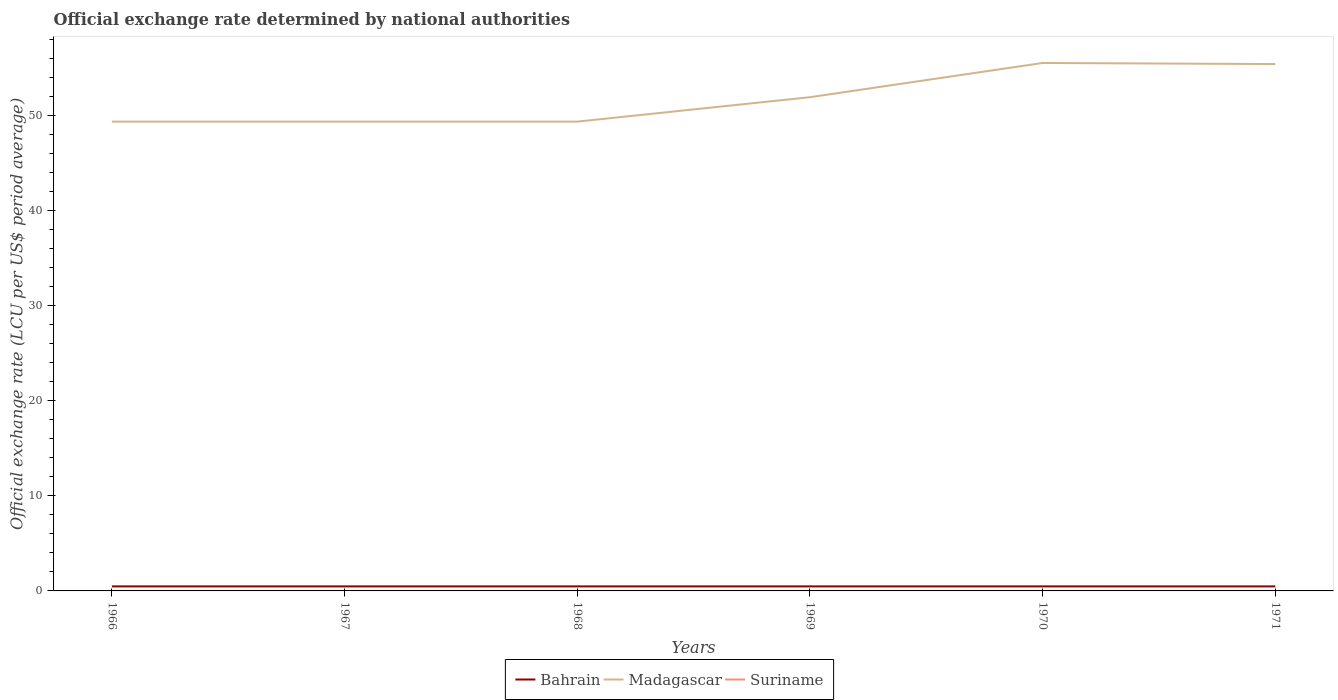Does the line corresponding to Bahrain intersect with the line corresponding to Madagascar?
Give a very brief answer. No. Across all years, what is the maximum official exchange rate in Bahrain?
Give a very brief answer. 0.47. In which year was the official exchange rate in Suriname maximum?
Keep it short and to the point. 1971. What is the total official exchange rate in Madagascar in the graph?
Provide a short and direct response. -2.57. What is the difference between the highest and the second highest official exchange rate in Bahrain?
Provide a succinct answer. 0. Is the official exchange rate in Bahrain strictly greater than the official exchange rate in Madagascar over the years?
Your answer should be very brief. Yes. How many lines are there?
Offer a very short reply. 3. How many years are there in the graph?
Provide a short and direct response. 6. Are the values on the major ticks of Y-axis written in scientific E-notation?
Keep it short and to the point. No. Where does the legend appear in the graph?
Provide a short and direct response. Bottom center. How many legend labels are there?
Your response must be concise. 3. How are the legend labels stacked?
Keep it short and to the point. Horizontal. What is the title of the graph?
Provide a short and direct response. Official exchange rate determined by national authorities. Does "Dominican Republic" appear as one of the legend labels in the graph?
Your answer should be very brief. No. What is the label or title of the Y-axis?
Ensure brevity in your answer.  Official exchange rate (LCU per US$ period average). What is the Official exchange rate (LCU per US$ period average) in Bahrain in 1966?
Keep it short and to the point. 0.48. What is the Official exchange rate (LCU per US$ period average) in Madagascar in 1966?
Your answer should be very brief. 49.37. What is the Official exchange rate (LCU per US$ period average) of Suriname in 1966?
Offer a terse response. 0. What is the Official exchange rate (LCU per US$ period average) in Bahrain in 1967?
Offer a very short reply. 0.48. What is the Official exchange rate (LCU per US$ period average) in Madagascar in 1967?
Offer a very short reply. 49.37. What is the Official exchange rate (LCU per US$ period average) of Suriname in 1967?
Provide a succinct answer. 0. What is the Official exchange rate (LCU per US$ period average) in Bahrain in 1968?
Provide a succinct answer. 0.48. What is the Official exchange rate (LCU per US$ period average) in Madagascar in 1968?
Keep it short and to the point. 49.37. What is the Official exchange rate (LCU per US$ period average) of Suriname in 1968?
Provide a short and direct response. 0. What is the Official exchange rate (LCU per US$ period average) of Bahrain in 1969?
Give a very brief answer. 0.48. What is the Official exchange rate (LCU per US$ period average) in Madagascar in 1969?
Your answer should be very brief. 51.94. What is the Official exchange rate (LCU per US$ period average) in Suriname in 1969?
Keep it short and to the point. 0. What is the Official exchange rate (LCU per US$ period average) of Bahrain in 1970?
Offer a terse response. 0.48. What is the Official exchange rate (LCU per US$ period average) of Madagascar in 1970?
Your answer should be very brief. 55.54. What is the Official exchange rate (LCU per US$ period average) of Suriname in 1970?
Offer a very short reply. 0. What is the Official exchange rate (LCU per US$ period average) of Bahrain in 1971?
Ensure brevity in your answer.  0.47. What is the Official exchange rate (LCU per US$ period average) in Madagascar in 1971?
Your response must be concise. 55.43. What is the Official exchange rate (LCU per US$ period average) of Suriname in 1971?
Make the answer very short. 0. Across all years, what is the maximum Official exchange rate (LCU per US$ period average) of Bahrain?
Give a very brief answer. 0.48. Across all years, what is the maximum Official exchange rate (LCU per US$ period average) of Madagascar?
Keep it short and to the point. 55.54. Across all years, what is the maximum Official exchange rate (LCU per US$ period average) of Suriname?
Provide a succinct answer. 0. Across all years, what is the minimum Official exchange rate (LCU per US$ period average) in Bahrain?
Offer a terse response. 0.47. Across all years, what is the minimum Official exchange rate (LCU per US$ period average) in Madagascar?
Offer a very short reply. 49.37. Across all years, what is the minimum Official exchange rate (LCU per US$ period average) in Suriname?
Give a very brief answer. 0. What is the total Official exchange rate (LCU per US$ period average) of Bahrain in the graph?
Give a very brief answer. 2.86. What is the total Official exchange rate (LCU per US$ period average) in Madagascar in the graph?
Provide a short and direct response. 311.02. What is the total Official exchange rate (LCU per US$ period average) in Suriname in the graph?
Make the answer very short. 0.01. What is the difference between the Official exchange rate (LCU per US$ period average) in Bahrain in 1966 and that in 1967?
Your answer should be very brief. 0. What is the difference between the Official exchange rate (LCU per US$ period average) of Bahrain in 1966 and that in 1968?
Make the answer very short. 0. What is the difference between the Official exchange rate (LCU per US$ period average) in Suriname in 1966 and that in 1968?
Your answer should be compact. 0. What is the difference between the Official exchange rate (LCU per US$ period average) in Madagascar in 1966 and that in 1969?
Ensure brevity in your answer.  -2.57. What is the difference between the Official exchange rate (LCU per US$ period average) in Bahrain in 1966 and that in 1970?
Your answer should be compact. 0. What is the difference between the Official exchange rate (LCU per US$ period average) in Madagascar in 1966 and that in 1970?
Make the answer very short. -6.17. What is the difference between the Official exchange rate (LCU per US$ period average) in Bahrain in 1966 and that in 1971?
Make the answer very short. 0. What is the difference between the Official exchange rate (LCU per US$ period average) in Madagascar in 1966 and that in 1971?
Give a very brief answer. -6.06. What is the difference between the Official exchange rate (LCU per US$ period average) in Bahrain in 1967 and that in 1968?
Your response must be concise. 0. What is the difference between the Official exchange rate (LCU per US$ period average) of Madagascar in 1967 and that in 1968?
Keep it short and to the point. 0. What is the difference between the Official exchange rate (LCU per US$ period average) in Suriname in 1967 and that in 1968?
Your response must be concise. 0. What is the difference between the Official exchange rate (LCU per US$ period average) in Bahrain in 1967 and that in 1969?
Keep it short and to the point. 0. What is the difference between the Official exchange rate (LCU per US$ period average) of Madagascar in 1967 and that in 1969?
Your response must be concise. -2.57. What is the difference between the Official exchange rate (LCU per US$ period average) in Suriname in 1967 and that in 1969?
Provide a short and direct response. 0. What is the difference between the Official exchange rate (LCU per US$ period average) in Bahrain in 1967 and that in 1970?
Your response must be concise. 0. What is the difference between the Official exchange rate (LCU per US$ period average) of Madagascar in 1967 and that in 1970?
Your response must be concise. -6.17. What is the difference between the Official exchange rate (LCU per US$ period average) in Bahrain in 1967 and that in 1971?
Provide a short and direct response. 0. What is the difference between the Official exchange rate (LCU per US$ period average) in Madagascar in 1967 and that in 1971?
Make the answer very short. -6.06. What is the difference between the Official exchange rate (LCU per US$ period average) of Suriname in 1967 and that in 1971?
Your response must be concise. 0. What is the difference between the Official exchange rate (LCU per US$ period average) in Madagascar in 1968 and that in 1969?
Give a very brief answer. -2.57. What is the difference between the Official exchange rate (LCU per US$ period average) in Madagascar in 1968 and that in 1970?
Offer a terse response. -6.17. What is the difference between the Official exchange rate (LCU per US$ period average) in Bahrain in 1968 and that in 1971?
Your response must be concise. 0. What is the difference between the Official exchange rate (LCU per US$ period average) of Madagascar in 1968 and that in 1971?
Your response must be concise. -6.06. What is the difference between the Official exchange rate (LCU per US$ period average) of Madagascar in 1969 and that in 1970?
Make the answer very short. -3.6. What is the difference between the Official exchange rate (LCU per US$ period average) of Suriname in 1969 and that in 1970?
Your answer should be very brief. 0. What is the difference between the Official exchange rate (LCU per US$ period average) of Bahrain in 1969 and that in 1971?
Make the answer very short. 0. What is the difference between the Official exchange rate (LCU per US$ period average) in Madagascar in 1969 and that in 1971?
Provide a succinct answer. -3.48. What is the difference between the Official exchange rate (LCU per US$ period average) of Bahrain in 1970 and that in 1971?
Your response must be concise. 0. What is the difference between the Official exchange rate (LCU per US$ period average) of Madagascar in 1970 and that in 1971?
Keep it short and to the point. 0.12. What is the difference between the Official exchange rate (LCU per US$ period average) in Bahrain in 1966 and the Official exchange rate (LCU per US$ period average) in Madagascar in 1967?
Offer a terse response. -48.89. What is the difference between the Official exchange rate (LCU per US$ period average) of Bahrain in 1966 and the Official exchange rate (LCU per US$ period average) of Suriname in 1967?
Provide a short and direct response. 0.47. What is the difference between the Official exchange rate (LCU per US$ period average) of Madagascar in 1966 and the Official exchange rate (LCU per US$ period average) of Suriname in 1967?
Offer a very short reply. 49.37. What is the difference between the Official exchange rate (LCU per US$ period average) in Bahrain in 1966 and the Official exchange rate (LCU per US$ period average) in Madagascar in 1968?
Provide a short and direct response. -48.89. What is the difference between the Official exchange rate (LCU per US$ period average) of Bahrain in 1966 and the Official exchange rate (LCU per US$ period average) of Suriname in 1968?
Provide a succinct answer. 0.47. What is the difference between the Official exchange rate (LCU per US$ period average) of Madagascar in 1966 and the Official exchange rate (LCU per US$ period average) of Suriname in 1968?
Make the answer very short. 49.37. What is the difference between the Official exchange rate (LCU per US$ period average) in Bahrain in 1966 and the Official exchange rate (LCU per US$ period average) in Madagascar in 1969?
Make the answer very short. -51.47. What is the difference between the Official exchange rate (LCU per US$ period average) of Bahrain in 1966 and the Official exchange rate (LCU per US$ period average) of Suriname in 1969?
Your answer should be compact. 0.47. What is the difference between the Official exchange rate (LCU per US$ period average) in Madagascar in 1966 and the Official exchange rate (LCU per US$ period average) in Suriname in 1969?
Your answer should be very brief. 49.37. What is the difference between the Official exchange rate (LCU per US$ period average) of Bahrain in 1966 and the Official exchange rate (LCU per US$ period average) of Madagascar in 1970?
Your response must be concise. -55.07. What is the difference between the Official exchange rate (LCU per US$ period average) in Bahrain in 1966 and the Official exchange rate (LCU per US$ period average) in Suriname in 1970?
Offer a terse response. 0.47. What is the difference between the Official exchange rate (LCU per US$ period average) in Madagascar in 1966 and the Official exchange rate (LCU per US$ period average) in Suriname in 1970?
Offer a very short reply. 49.37. What is the difference between the Official exchange rate (LCU per US$ period average) of Bahrain in 1966 and the Official exchange rate (LCU per US$ period average) of Madagascar in 1971?
Your answer should be compact. -54.95. What is the difference between the Official exchange rate (LCU per US$ period average) of Bahrain in 1966 and the Official exchange rate (LCU per US$ period average) of Suriname in 1971?
Your response must be concise. 0.47. What is the difference between the Official exchange rate (LCU per US$ period average) of Madagascar in 1966 and the Official exchange rate (LCU per US$ period average) of Suriname in 1971?
Your answer should be compact. 49.37. What is the difference between the Official exchange rate (LCU per US$ period average) of Bahrain in 1967 and the Official exchange rate (LCU per US$ period average) of Madagascar in 1968?
Offer a very short reply. -48.89. What is the difference between the Official exchange rate (LCU per US$ period average) in Bahrain in 1967 and the Official exchange rate (LCU per US$ period average) in Suriname in 1968?
Make the answer very short. 0.47. What is the difference between the Official exchange rate (LCU per US$ period average) in Madagascar in 1967 and the Official exchange rate (LCU per US$ period average) in Suriname in 1968?
Your answer should be very brief. 49.37. What is the difference between the Official exchange rate (LCU per US$ period average) of Bahrain in 1967 and the Official exchange rate (LCU per US$ period average) of Madagascar in 1969?
Provide a short and direct response. -51.47. What is the difference between the Official exchange rate (LCU per US$ period average) in Bahrain in 1967 and the Official exchange rate (LCU per US$ period average) in Suriname in 1969?
Ensure brevity in your answer.  0.47. What is the difference between the Official exchange rate (LCU per US$ period average) in Madagascar in 1967 and the Official exchange rate (LCU per US$ period average) in Suriname in 1969?
Your response must be concise. 49.37. What is the difference between the Official exchange rate (LCU per US$ period average) in Bahrain in 1967 and the Official exchange rate (LCU per US$ period average) in Madagascar in 1970?
Ensure brevity in your answer.  -55.07. What is the difference between the Official exchange rate (LCU per US$ period average) in Bahrain in 1967 and the Official exchange rate (LCU per US$ period average) in Suriname in 1970?
Your response must be concise. 0.47. What is the difference between the Official exchange rate (LCU per US$ period average) of Madagascar in 1967 and the Official exchange rate (LCU per US$ period average) of Suriname in 1970?
Provide a succinct answer. 49.37. What is the difference between the Official exchange rate (LCU per US$ period average) of Bahrain in 1967 and the Official exchange rate (LCU per US$ period average) of Madagascar in 1971?
Ensure brevity in your answer.  -54.95. What is the difference between the Official exchange rate (LCU per US$ period average) of Bahrain in 1967 and the Official exchange rate (LCU per US$ period average) of Suriname in 1971?
Your response must be concise. 0.47. What is the difference between the Official exchange rate (LCU per US$ period average) of Madagascar in 1967 and the Official exchange rate (LCU per US$ period average) of Suriname in 1971?
Offer a very short reply. 49.37. What is the difference between the Official exchange rate (LCU per US$ period average) of Bahrain in 1968 and the Official exchange rate (LCU per US$ period average) of Madagascar in 1969?
Provide a succinct answer. -51.47. What is the difference between the Official exchange rate (LCU per US$ period average) of Bahrain in 1968 and the Official exchange rate (LCU per US$ period average) of Suriname in 1969?
Your answer should be very brief. 0.47. What is the difference between the Official exchange rate (LCU per US$ period average) in Madagascar in 1968 and the Official exchange rate (LCU per US$ period average) in Suriname in 1969?
Provide a succinct answer. 49.37. What is the difference between the Official exchange rate (LCU per US$ period average) of Bahrain in 1968 and the Official exchange rate (LCU per US$ period average) of Madagascar in 1970?
Your answer should be compact. -55.07. What is the difference between the Official exchange rate (LCU per US$ period average) of Bahrain in 1968 and the Official exchange rate (LCU per US$ period average) of Suriname in 1970?
Ensure brevity in your answer.  0.47. What is the difference between the Official exchange rate (LCU per US$ period average) of Madagascar in 1968 and the Official exchange rate (LCU per US$ period average) of Suriname in 1970?
Offer a terse response. 49.37. What is the difference between the Official exchange rate (LCU per US$ period average) of Bahrain in 1968 and the Official exchange rate (LCU per US$ period average) of Madagascar in 1971?
Your answer should be very brief. -54.95. What is the difference between the Official exchange rate (LCU per US$ period average) of Bahrain in 1968 and the Official exchange rate (LCU per US$ period average) of Suriname in 1971?
Offer a terse response. 0.47. What is the difference between the Official exchange rate (LCU per US$ period average) in Madagascar in 1968 and the Official exchange rate (LCU per US$ period average) in Suriname in 1971?
Make the answer very short. 49.37. What is the difference between the Official exchange rate (LCU per US$ period average) in Bahrain in 1969 and the Official exchange rate (LCU per US$ period average) in Madagascar in 1970?
Keep it short and to the point. -55.07. What is the difference between the Official exchange rate (LCU per US$ period average) in Bahrain in 1969 and the Official exchange rate (LCU per US$ period average) in Suriname in 1970?
Ensure brevity in your answer.  0.47. What is the difference between the Official exchange rate (LCU per US$ period average) in Madagascar in 1969 and the Official exchange rate (LCU per US$ period average) in Suriname in 1970?
Offer a terse response. 51.94. What is the difference between the Official exchange rate (LCU per US$ period average) of Bahrain in 1969 and the Official exchange rate (LCU per US$ period average) of Madagascar in 1971?
Your response must be concise. -54.95. What is the difference between the Official exchange rate (LCU per US$ period average) of Bahrain in 1969 and the Official exchange rate (LCU per US$ period average) of Suriname in 1971?
Provide a short and direct response. 0.47. What is the difference between the Official exchange rate (LCU per US$ period average) in Madagascar in 1969 and the Official exchange rate (LCU per US$ period average) in Suriname in 1971?
Make the answer very short. 51.94. What is the difference between the Official exchange rate (LCU per US$ period average) in Bahrain in 1970 and the Official exchange rate (LCU per US$ period average) in Madagascar in 1971?
Make the answer very short. -54.95. What is the difference between the Official exchange rate (LCU per US$ period average) of Bahrain in 1970 and the Official exchange rate (LCU per US$ period average) of Suriname in 1971?
Keep it short and to the point. 0.47. What is the difference between the Official exchange rate (LCU per US$ period average) of Madagascar in 1970 and the Official exchange rate (LCU per US$ period average) of Suriname in 1971?
Give a very brief answer. 55.54. What is the average Official exchange rate (LCU per US$ period average) of Bahrain per year?
Your answer should be very brief. 0.48. What is the average Official exchange rate (LCU per US$ period average) in Madagascar per year?
Offer a very short reply. 51.84. What is the average Official exchange rate (LCU per US$ period average) of Suriname per year?
Your answer should be very brief. 0. In the year 1966, what is the difference between the Official exchange rate (LCU per US$ period average) of Bahrain and Official exchange rate (LCU per US$ period average) of Madagascar?
Ensure brevity in your answer.  -48.89. In the year 1966, what is the difference between the Official exchange rate (LCU per US$ period average) in Bahrain and Official exchange rate (LCU per US$ period average) in Suriname?
Make the answer very short. 0.47. In the year 1966, what is the difference between the Official exchange rate (LCU per US$ period average) of Madagascar and Official exchange rate (LCU per US$ period average) of Suriname?
Offer a very short reply. 49.37. In the year 1967, what is the difference between the Official exchange rate (LCU per US$ period average) in Bahrain and Official exchange rate (LCU per US$ period average) in Madagascar?
Give a very brief answer. -48.89. In the year 1967, what is the difference between the Official exchange rate (LCU per US$ period average) of Bahrain and Official exchange rate (LCU per US$ period average) of Suriname?
Offer a very short reply. 0.47. In the year 1967, what is the difference between the Official exchange rate (LCU per US$ period average) in Madagascar and Official exchange rate (LCU per US$ period average) in Suriname?
Provide a succinct answer. 49.37. In the year 1968, what is the difference between the Official exchange rate (LCU per US$ period average) in Bahrain and Official exchange rate (LCU per US$ period average) in Madagascar?
Keep it short and to the point. -48.89. In the year 1968, what is the difference between the Official exchange rate (LCU per US$ period average) of Bahrain and Official exchange rate (LCU per US$ period average) of Suriname?
Provide a succinct answer. 0.47. In the year 1968, what is the difference between the Official exchange rate (LCU per US$ period average) of Madagascar and Official exchange rate (LCU per US$ period average) of Suriname?
Provide a short and direct response. 49.37. In the year 1969, what is the difference between the Official exchange rate (LCU per US$ period average) in Bahrain and Official exchange rate (LCU per US$ period average) in Madagascar?
Your response must be concise. -51.47. In the year 1969, what is the difference between the Official exchange rate (LCU per US$ period average) of Bahrain and Official exchange rate (LCU per US$ period average) of Suriname?
Offer a very short reply. 0.47. In the year 1969, what is the difference between the Official exchange rate (LCU per US$ period average) of Madagascar and Official exchange rate (LCU per US$ period average) of Suriname?
Your answer should be very brief. 51.94. In the year 1970, what is the difference between the Official exchange rate (LCU per US$ period average) in Bahrain and Official exchange rate (LCU per US$ period average) in Madagascar?
Give a very brief answer. -55.07. In the year 1970, what is the difference between the Official exchange rate (LCU per US$ period average) of Bahrain and Official exchange rate (LCU per US$ period average) of Suriname?
Make the answer very short. 0.47. In the year 1970, what is the difference between the Official exchange rate (LCU per US$ period average) in Madagascar and Official exchange rate (LCU per US$ period average) in Suriname?
Offer a very short reply. 55.54. In the year 1971, what is the difference between the Official exchange rate (LCU per US$ period average) in Bahrain and Official exchange rate (LCU per US$ period average) in Madagascar?
Offer a very short reply. -54.95. In the year 1971, what is the difference between the Official exchange rate (LCU per US$ period average) of Bahrain and Official exchange rate (LCU per US$ period average) of Suriname?
Ensure brevity in your answer.  0.47. In the year 1971, what is the difference between the Official exchange rate (LCU per US$ period average) in Madagascar and Official exchange rate (LCU per US$ period average) in Suriname?
Offer a very short reply. 55.42. What is the ratio of the Official exchange rate (LCU per US$ period average) of Bahrain in 1966 to that in 1967?
Your response must be concise. 1. What is the ratio of the Official exchange rate (LCU per US$ period average) in Bahrain in 1966 to that in 1968?
Ensure brevity in your answer.  1. What is the ratio of the Official exchange rate (LCU per US$ period average) in Suriname in 1966 to that in 1968?
Give a very brief answer. 1. What is the ratio of the Official exchange rate (LCU per US$ period average) of Madagascar in 1966 to that in 1969?
Offer a very short reply. 0.95. What is the ratio of the Official exchange rate (LCU per US$ period average) in Bahrain in 1966 to that in 1970?
Provide a short and direct response. 1. What is the ratio of the Official exchange rate (LCU per US$ period average) in Bahrain in 1966 to that in 1971?
Ensure brevity in your answer.  1. What is the ratio of the Official exchange rate (LCU per US$ period average) of Madagascar in 1966 to that in 1971?
Your response must be concise. 0.89. What is the ratio of the Official exchange rate (LCU per US$ period average) in Bahrain in 1967 to that in 1968?
Offer a very short reply. 1. What is the ratio of the Official exchange rate (LCU per US$ period average) of Madagascar in 1967 to that in 1968?
Offer a very short reply. 1. What is the ratio of the Official exchange rate (LCU per US$ period average) of Suriname in 1967 to that in 1968?
Keep it short and to the point. 1. What is the ratio of the Official exchange rate (LCU per US$ period average) of Madagascar in 1967 to that in 1969?
Offer a terse response. 0.95. What is the ratio of the Official exchange rate (LCU per US$ period average) of Madagascar in 1967 to that in 1970?
Provide a succinct answer. 0.89. What is the ratio of the Official exchange rate (LCU per US$ period average) in Suriname in 1967 to that in 1970?
Offer a terse response. 1. What is the ratio of the Official exchange rate (LCU per US$ period average) of Bahrain in 1967 to that in 1971?
Your answer should be very brief. 1. What is the ratio of the Official exchange rate (LCU per US$ period average) in Madagascar in 1967 to that in 1971?
Your answer should be very brief. 0.89. What is the ratio of the Official exchange rate (LCU per US$ period average) of Suriname in 1967 to that in 1971?
Your response must be concise. 1. What is the ratio of the Official exchange rate (LCU per US$ period average) of Madagascar in 1968 to that in 1969?
Offer a terse response. 0.95. What is the ratio of the Official exchange rate (LCU per US$ period average) in Suriname in 1968 to that in 1969?
Your response must be concise. 1. What is the ratio of the Official exchange rate (LCU per US$ period average) in Bahrain in 1968 to that in 1970?
Offer a very short reply. 1. What is the ratio of the Official exchange rate (LCU per US$ period average) of Bahrain in 1968 to that in 1971?
Provide a succinct answer. 1. What is the ratio of the Official exchange rate (LCU per US$ period average) in Madagascar in 1968 to that in 1971?
Ensure brevity in your answer.  0.89. What is the ratio of the Official exchange rate (LCU per US$ period average) in Suriname in 1968 to that in 1971?
Offer a very short reply. 1. What is the ratio of the Official exchange rate (LCU per US$ period average) in Bahrain in 1969 to that in 1970?
Give a very brief answer. 1. What is the ratio of the Official exchange rate (LCU per US$ period average) of Madagascar in 1969 to that in 1970?
Ensure brevity in your answer.  0.94. What is the ratio of the Official exchange rate (LCU per US$ period average) in Madagascar in 1969 to that in 1971?
Provide a succinct answer. 0.94. What is the difference between the highest and the second highest Official exchange rate (LCU per US$ period average) of Bahrain?
Provide a succinct answer. 0. What is the difference between the highest and the second highest Official exchange rate (LCU per US$ period average) of Madagascar?
Your answer should be compact. 0.12. What is the difference between the highest and the lowest Official exchange rate (LCU per US$ period average) in Bahrain?
Make the answer very short. 0. What is the difference between the highest and the lowest Official exchange rate (LCU per US$ period average) of Madagascar?
Provide a succinct answer. 6.17. 